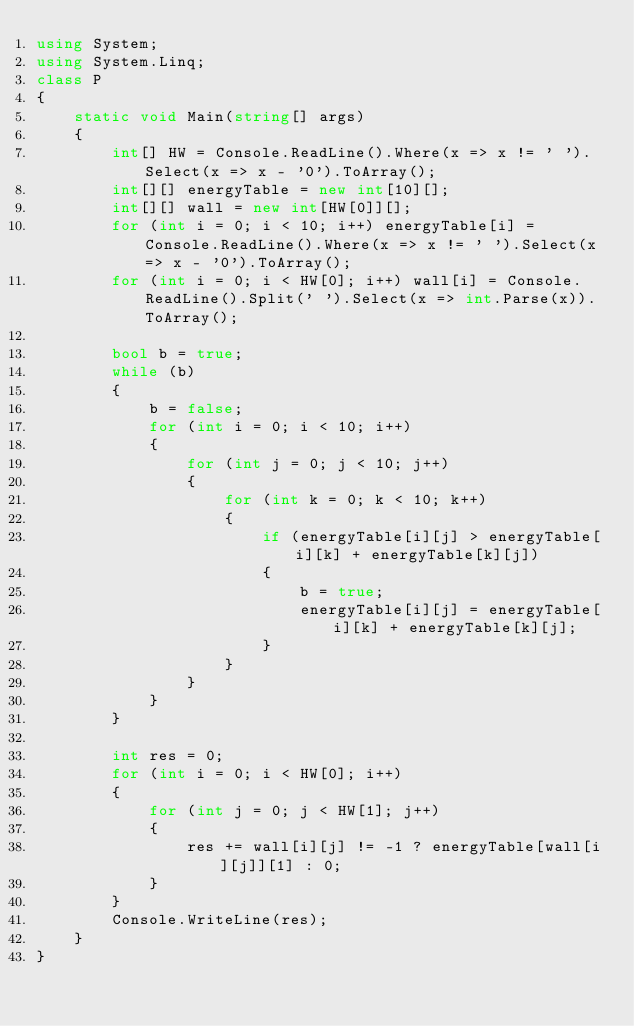<code> <loc_0><loc_0><loc_500><loc_500><_C#_>using System;
using System.Linq;
class P
{
    static void Main(string[] args)
    {
        int[] HW = Console.ReadLine().Where(x => x != ' ').Select(x => x - '0').ToArray();
        int[][] energyTable = new int[10][];
        int[][] wall = new int[HW[0]][];
        for (int i = 0; i < 10; i++) energyTable[i] = Console.ReadLine().Where(x => x != ' ').Select(x => x - '0').ToArray();
        for (int i = 0; i < HW[0]; i++) wall[i] = Console.ReadLine().Split(' ').Select(x => int.Parse(x)).ToArray();

        bool b = true;
        while (b)
        {
            b = false;
            for (int i = 0; i < 10; i++)
            {
                for (int j = 0; j < 10; j++)
                {
                    for (int k = 0; k < 10; k++)
                    {
                        if (energyTable[i][j] > energyTable[i][k] + energyTable[k][j])
                        {
                            b = true;
                            energyTable[i][j] = energyTable[i][k] + energyTable[k][j];
                        }
                    }
                }
            }
        }

        int res = 0;
        for (int i = 0; i < HW[0]; i++)
        {
            for (int j = 0; j < HW[1]; j++)
            {
                res += wall[i][j] != -1 ? energyTable[wall[i][j]][1] : 0;
            }
        }
        Console.WriteLine(res);
    }
}</code> 